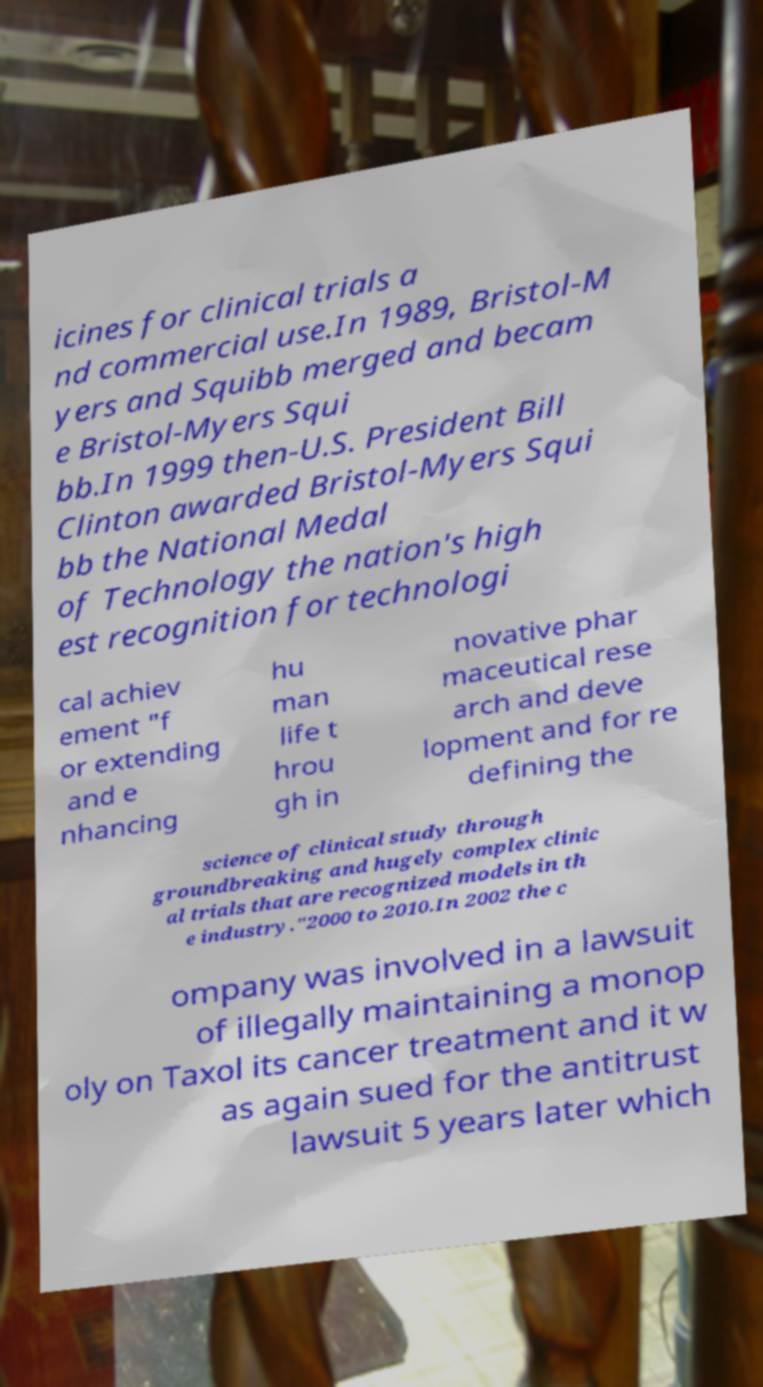Can you read and provide the text displayed in the image?This photo seems to have some interesting text. Can you extract and type it out for me? icines for clinical trials a nd commercial use.In 1989, Bristol-M yers and Squibb merged and becam e Bristol-Myers Squi bb.In 1999 then-U.S. President Bill Clinton awarded Bristol-Myers Squi bb the National Medal of Technology the nation's high est recognition for technologi cal achiev ement "f or extending and e nhancing hu man life t hrou gh in novative phar maceutical rese arch and deve lopment and for re defining the science of clinical study through groundbreaking and hugely complex clinic al trials that are recognized models in th e industry."2000 to 2010.In 2002 the c ompany was involved in a lawsuit of illegally maintaining a monop oly on Taxol its cancer treatment and it w as again sued for the antitrust lawsuit 5 years later which 